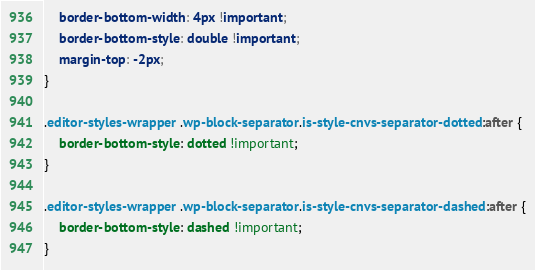<code> <loc_0><loc_0><loc_500><loc_500><_CSS_>	border-bottom-width: 4px !important;
	border-bottom-style: double !important;
	margin-top: -2px;
}

.editor-styles-wrapper .wp-block-separator.is-style-cnvs-separator-dotted:after {
	border-bottom-style: dotted !important;
}

.editor-styles-wrapper .wp-block-separator.is-style-cnvs-separator-dashed:after {
	border-bottom-style: dashed !important;
}
</code> 